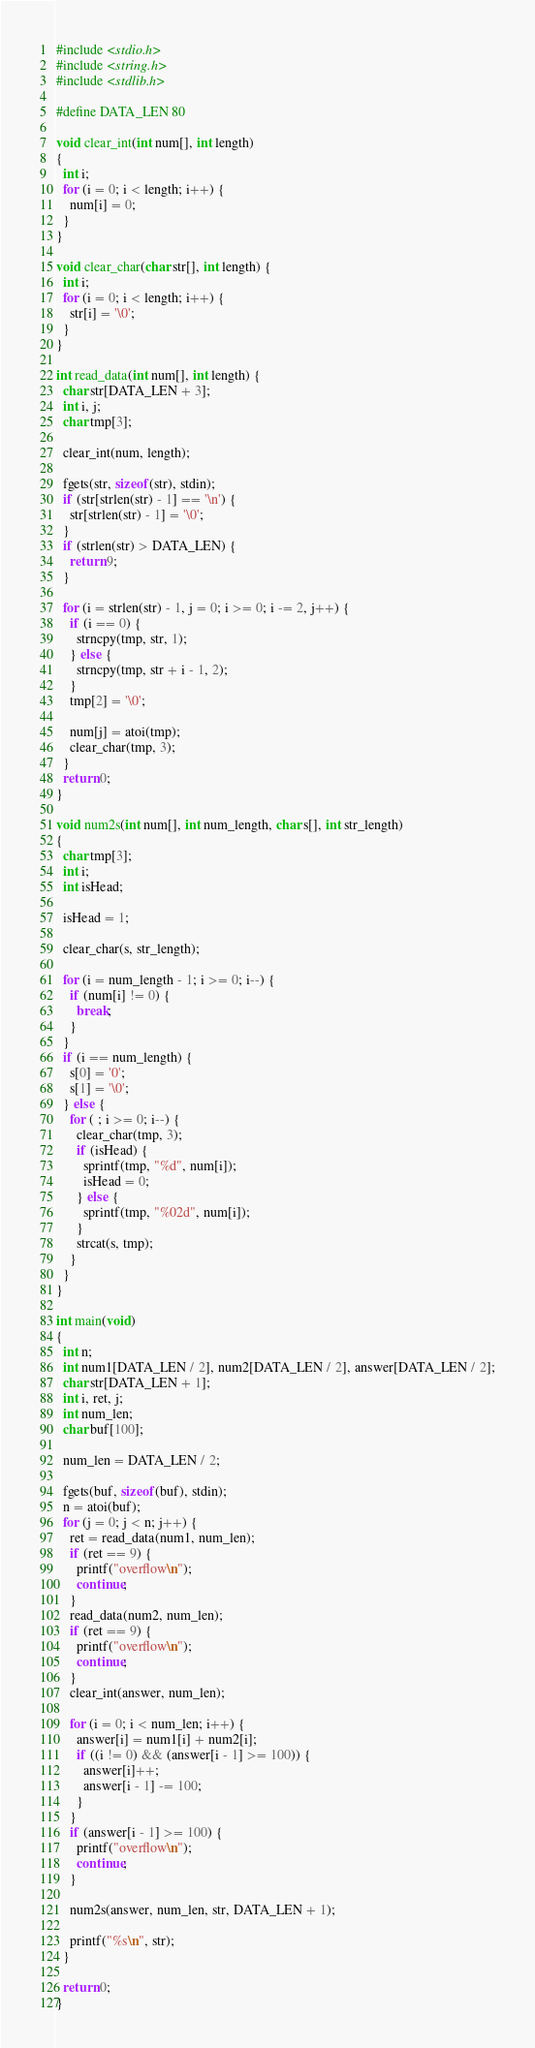Convert code to text. <code><loc_0><loc_0><loc_500><loc_500><_C_>#include <stdio.h>
#include <string.h>
#include <stdlib.h>

#define DATA_LEN 80

void clear_int(int num[], int length)
{
  int i;
  for (i = 0; i < length; i++) {
    num[i] = 0;
  }
}

void clear_char(char str[], int length) {
  int i;
  for (i = 0; i < length; i++) {
    str[i] = '\0';
  }
}

int read_data(int num[], int length) {
  char str[DATA_LEN + 3];
  int i, j;
  char tmp[3];

  clear_int(num, length);

  fgets(str, sizeof(str), stdin);
  if (str[strlen(str) - 1] == '\n') {
    str[strlen(str) - 1] = '\0';
  }
  if (strlen(str) > DATA_LEN) {
    return 9;
  }

  for (i = strlen(str) - 1, j = 0; i >= 0; i -= 2, j++) {
    if (i == 0) {
      strncpy(tmp, str, 1);
    } else { 
      strncpy(tmp, str + i - 1, 2);
    }
    tmp[2] = '\0';

    num[j] = atoi(tmp);
    clear_char(tmp, 3);
  }
  return 0;
}

void num2s(int num[], int num_length, char s[], int str_length)
{
  char tmp[3];
  int i;
  int isHead;

  isHead = 1;

  clear_char(s, str_length);

  for (i = num_length - 1; i >= 0; i--) {
    if (num[i] != 0) {
      break;
    }
  }
  if (i == num_length) {
    s[0] = '0';
    s[1] = '\0';
  } else {
    for ( ; i >= 0; i--) {
      clear_char(tmp, 3);
      if (isHead) {
        sprintf(tmp, "%d", num[i]);
        isHead = 0;
      } else {
        sprintf(tmp, "%02d", num[i]);
      }
      strcat(s, tmp);
    }
  }
}

int main(void)
{
  int n;
  int num1[DATA_LEN / 2], num2[DATA_LEN / 2], answer[DATA_LEN / 2];
  char str[DATA_LEN + 1];
  int i, ret, j;
  int num_len;
  char buf[100];

  num_len = DATA_LEN / 2;

  fgets(buf, sizeof(buf), stdin);
  n = atoi(buf);
  for (j = 0; j < n; j++) {
    ret = read_data(num1, num_len);
    if (ret == 9) {
      printf("overflow\n");
      continue;
    }
    read_data(num2, num_len);
    if (ret == 9) {
      printf("overflow\n");
      continue;
    }
    clear_int(answer, num_len);

    for (i = 0; i < num_len; i++) {
      answer[i] = num1[i] + num2[i];
      if ((i != 0) && (answer[i - 1] >= 100)) {
        answer[i]++;
        answer[i - 1] -= 100;
      }
    }
    if (answer[i - 1] >= 100) {
      printf("overflow\n");
      continue;
    }

    num2s(answer, num_len, str, DATA_LEN + 1);

    printf("%s\n", str);
  }

  return 0;
}</code> 